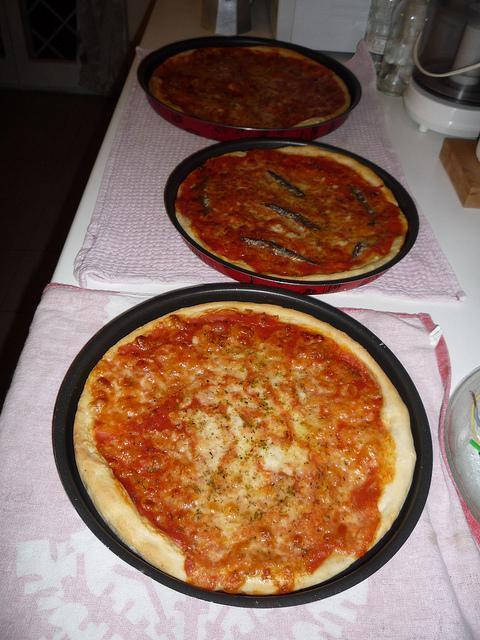How many pizzas are here?
Give a very brief answer. 3. How many pizzas is for dinner?
Give a very brief answer. 3. How many pizzas are there?
Give a very brief answer. 3. 